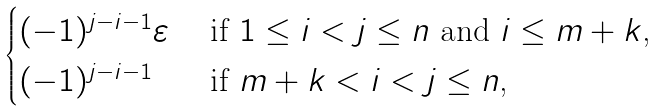<formula> <loc_0><loc_0><loc_500><loc_500>\begin{cases} ( - 1 ) ^ { j - i - 1 } \varepsilon & \text { if $1\leq i<j\leq n$ and $i\leq m+k$,} \\ ( - 1 ) ^ { j - i - 1 } & \text { if $m+k< i<j\leq n$,} \end{cases}</formula> 